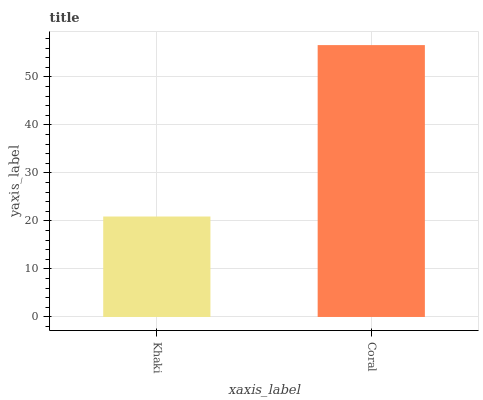Is Khaki the minimum?
Answer yes or no. Yes. Is Coral the maximum?
Answer yes or no. Yes. Is Coral the minimum?
Answer yes or no. No. Is Coral greater than Khaki?
Answer yes or no. Yes. Is Khaki less than Coral?
Answer yes or no. Yes. Is Khaki greater than Coral?
Answer yes or no. No. Is Coral less than Khaki?
Answer yes or no. No. Is Coral the high median?
Answer yes or no. Yes. Is Khaki the low median?
Answer yes or no. Yes. Is Khaki the high median?
Answer yes or no. No. Is Coral the low median?
Answer yes or no. No. 